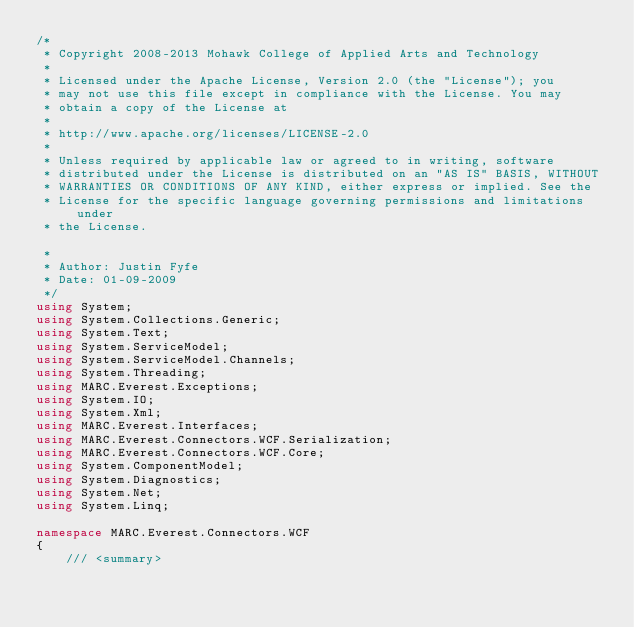<code> <loc_0><loc_0><loc_500><loc_500><_C#_>/* 
 * Copyright 2008-2013 Mohawk College of Applied Arts and Technology
 * 
 * Licensed under the Apache License, Version 2.0 (the "License"); you 
 * may not use this file except in compliance with the License. You may 
 * obtain a copy of the License at 
 * 
 * http://www.apache.org/licenses/LICENSE-2.0 
 * 
 * Unless required by applicable law or agreed to in writing, software
 * distributed under the License is distributed on an "AS IS" BASIS, WITHOUT
 * WARRANTIES OR CONDITIONS OF ANY KIND, either express or implied. See the 
 * License for the specific language governing permissions and limitations under 
 * the License.

 * 
 * Author: Justin Fyfe
 * Date: 01-09-2009
 */
using System;
using System.Collections.Generic;
using System.Text;
using System.ServiceModel;
using System.ServiceModel.Channels;
using System.Threading;
using MARC.Everest.Exceptions;
using System.IO;
using System.Xml;
using MARC.Everest.Interfaces;
using MARC.Everest.Connectors.WCF.Serialization;
using MARC.Everest.Connectors.WCF.Core;
using System.ComponentModel;
using System.Diagnostics;
using System.Net;
using System.Linq;

namespace MARC.Everest.Connectors.WCF
{
    /// <summary></code> 